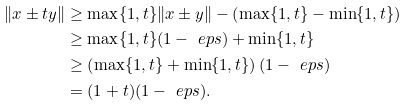Convert formula to latex. <formula><loc_0><loc_0><loc_500><loc_500>\| x \pm t y \| & \geq \max \{ 1 , t \} \| x \pm y \| - \left ( \max \{ 1 , t \} - \min \{ 1 , t \} \right ) \\ & \geq \max \{ 1 , t \} ( 1 - \ e p s ) + \min \{ 1 , t \} \\ & \geq \left ( \max \{ 1 , t \} + \min \{ 1 , t \} \right ) ( 1 - \ e p s ) \\ & = ( 1 + t ) ( 1 - \ e p s ) .</formula> 